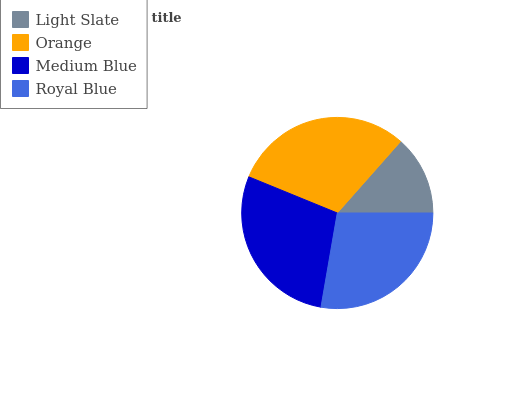Is Light Slate the minimum?
Answer yes or no. Yes. Is Orange the maximum?
Answer yes or no. Yes. Is Medium Blue the minimum?
Answer yes or no. No. Is Medium Blue the maximum?
Answer yes or no. No. Is Orange greater than Medium Blue?
Answer yes or no. Yes. Is Medium Blue less than Orange?
Answer yes or no. Yes. Is Medium Blue greater than Orange?
Answer yes or no. No. Is Orange less than Medium Blue?
Answer yes or no. No. Is Medium Blue the high median?
Answer yes or no. Yes. Is Royal Blue the low median?
Answer yes or no. Yes. Is Light Slate the high median?
Answer yes or no. No. Is Light Slate the low median?
Answer yes or no. No. 